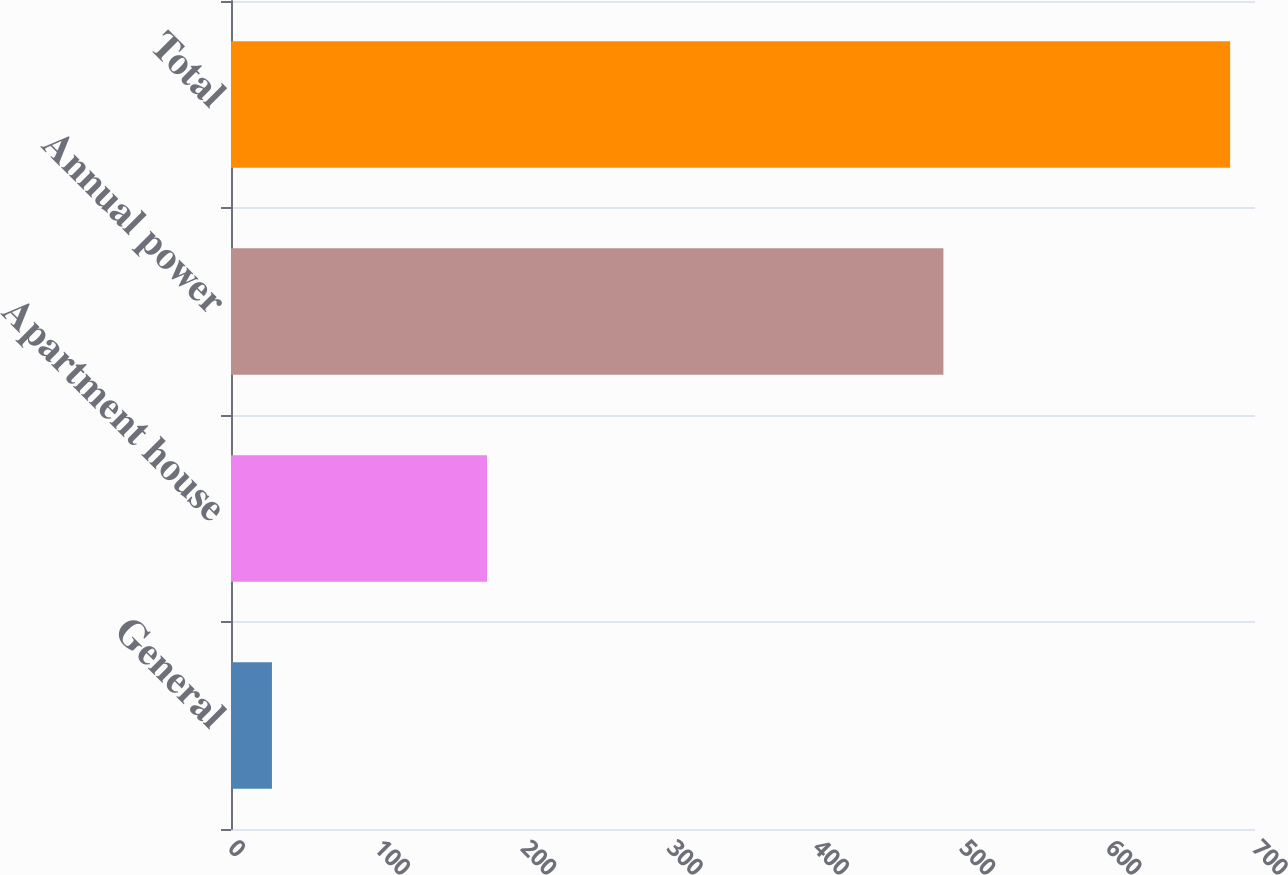Convert chart to OTSL. <chart><loc_0><loc_0><loc_500><loc_500><bar_chart><fcel>General<fcel>Apartment house<fcel>Annual power<fcel>Total<nl><fcel>28<fcel>175<fcel>487<fcel>683<nl></chart> 